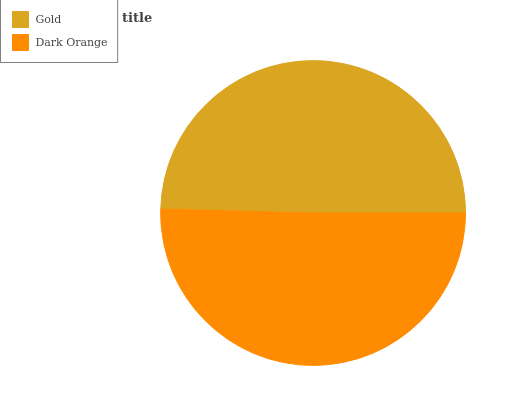Is Gold the minimum?
Answer yes or no. Yes. Is Dark Orange the maximum?
Answer yes or no. Yes. Is Dark Orange the minimum?
Answer yes or no. No. Is Dark Orange greater than Gold?
Answer yes or no. Yes. Is Gold less than Dark Orange?
Answer yes or no. Yes. Is Gold greater than Dark Orange?
Answer yes or no. No. Is Dark Orange less than Gold?
Answer yes or no. No. Is Dark Orange the high median?
Answer yes or no. Yes. Is Gold the low median?
Answer yes or no. Yes. Is Gold the high median?
Answer yes or no. No. Is Dark Orange the low median?
Answer yes or no. No. 